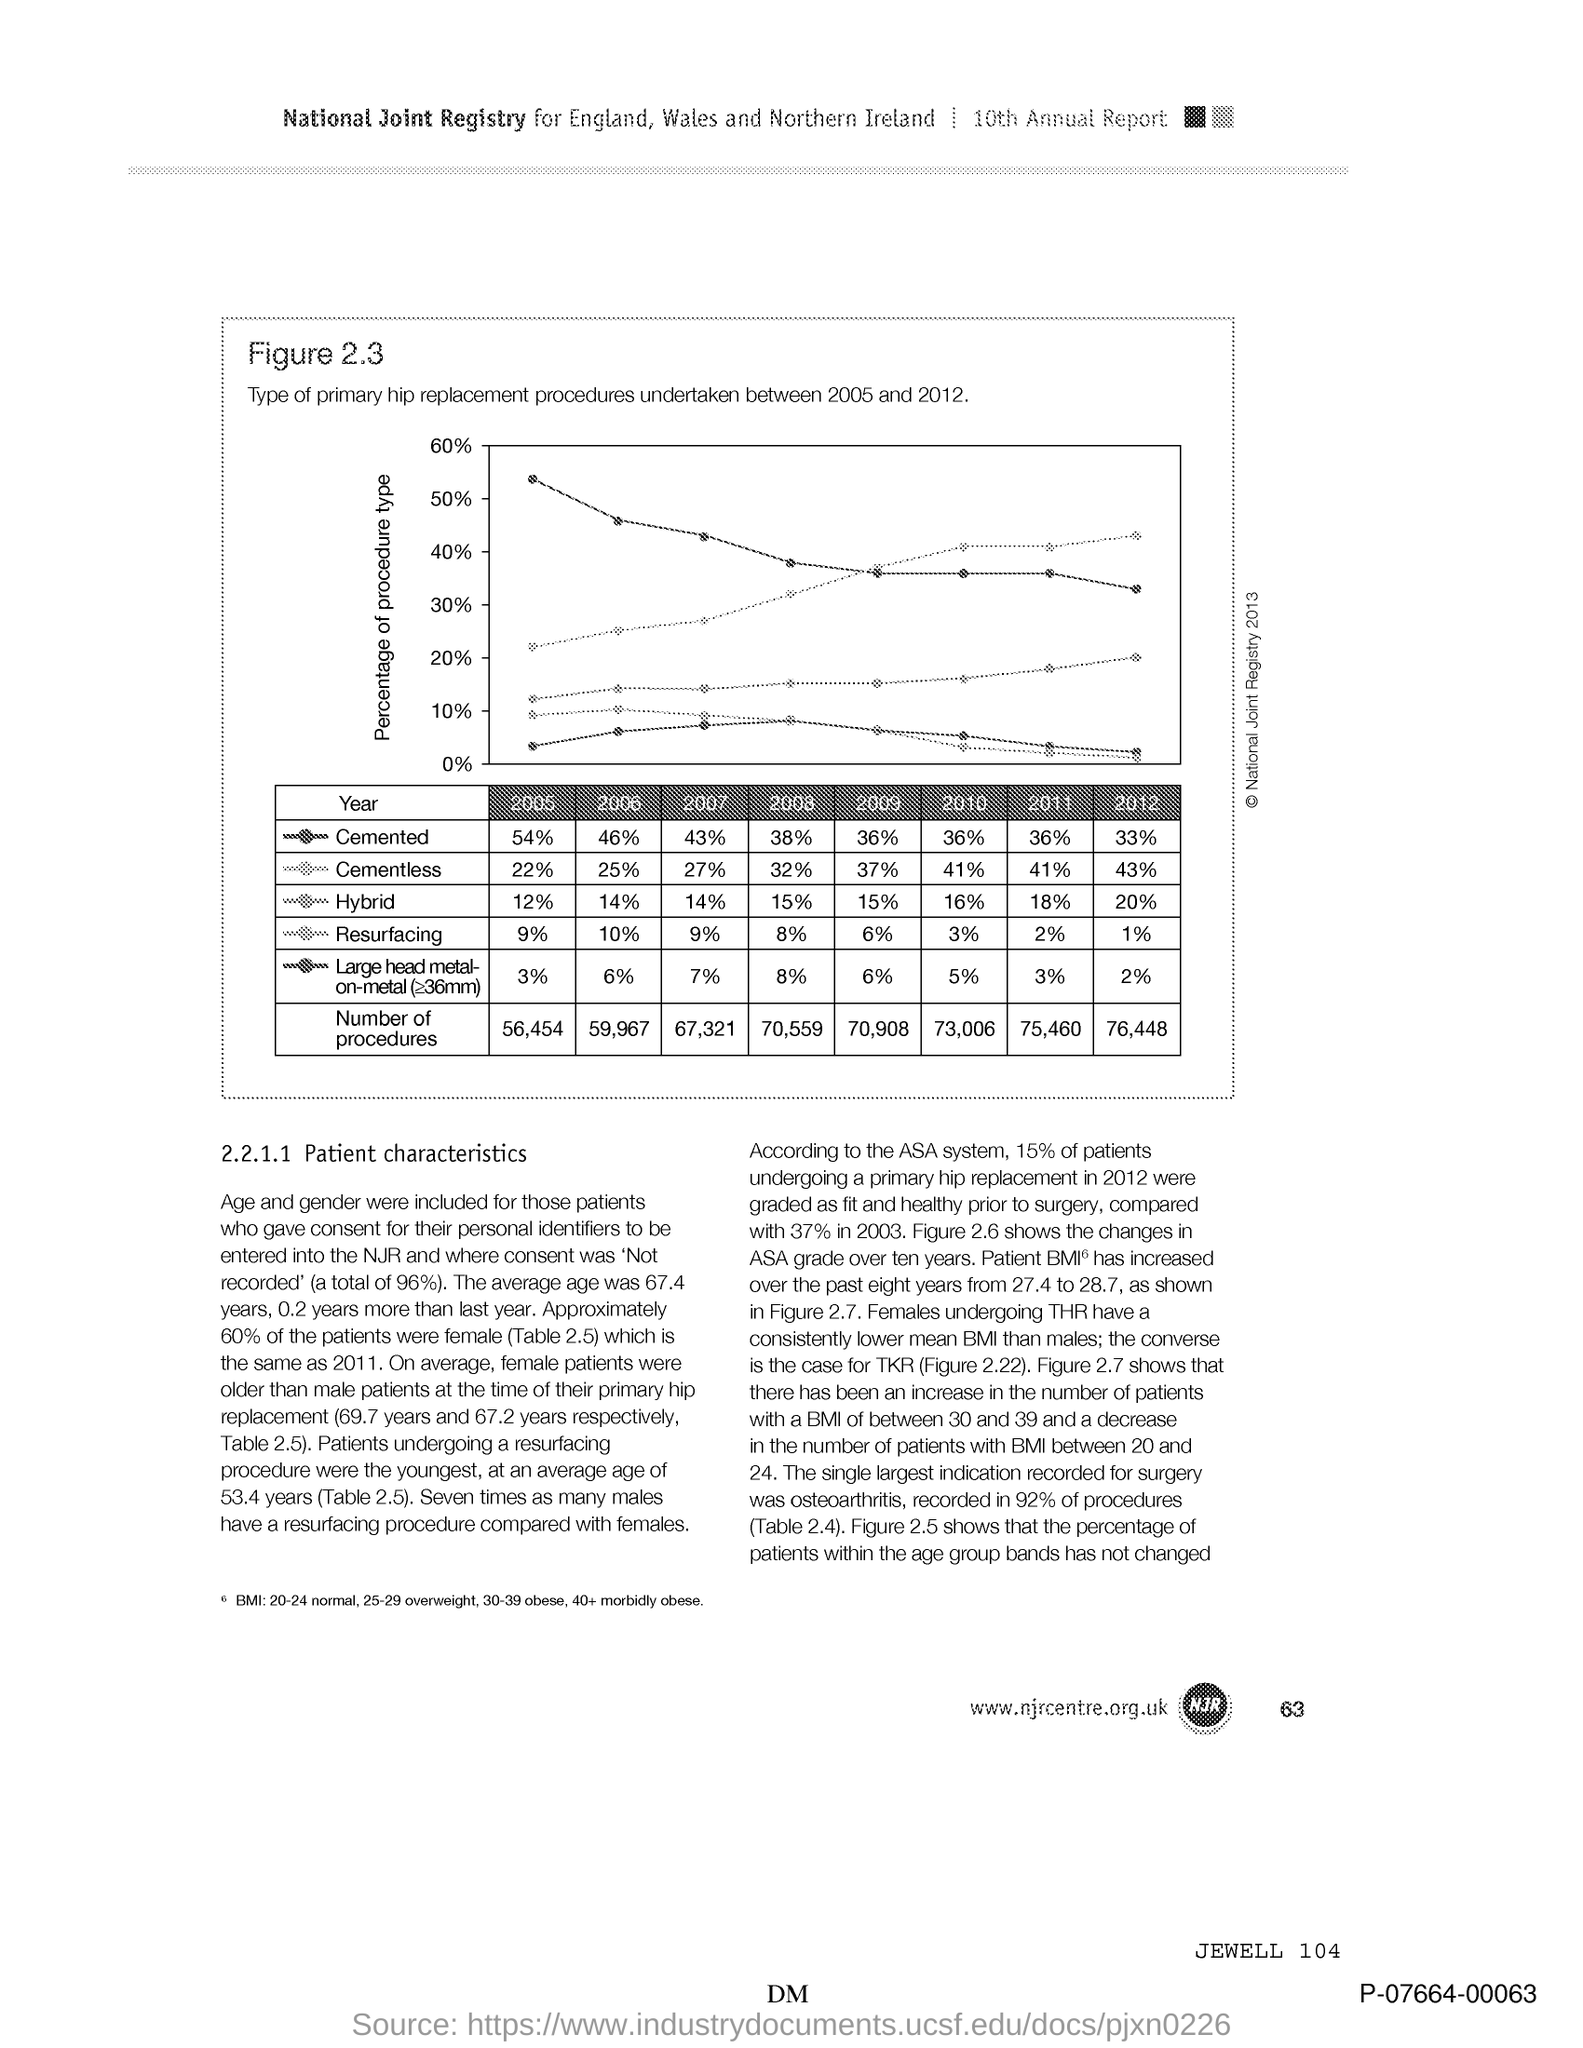Point out several critical features in this image. In 2011, it was determined that "cemented" made up 36% of a certain percentage. In 2005, it was determined that "cemented" accounted for 54% of a certain phenomenon. In 2006, it was reported that the percentage of "cementless" was 25%. In 2006, the percentage of "cemented" was 46%. In 2005, it was reported that approximately 22% of hip replacements used a cementless technique. 